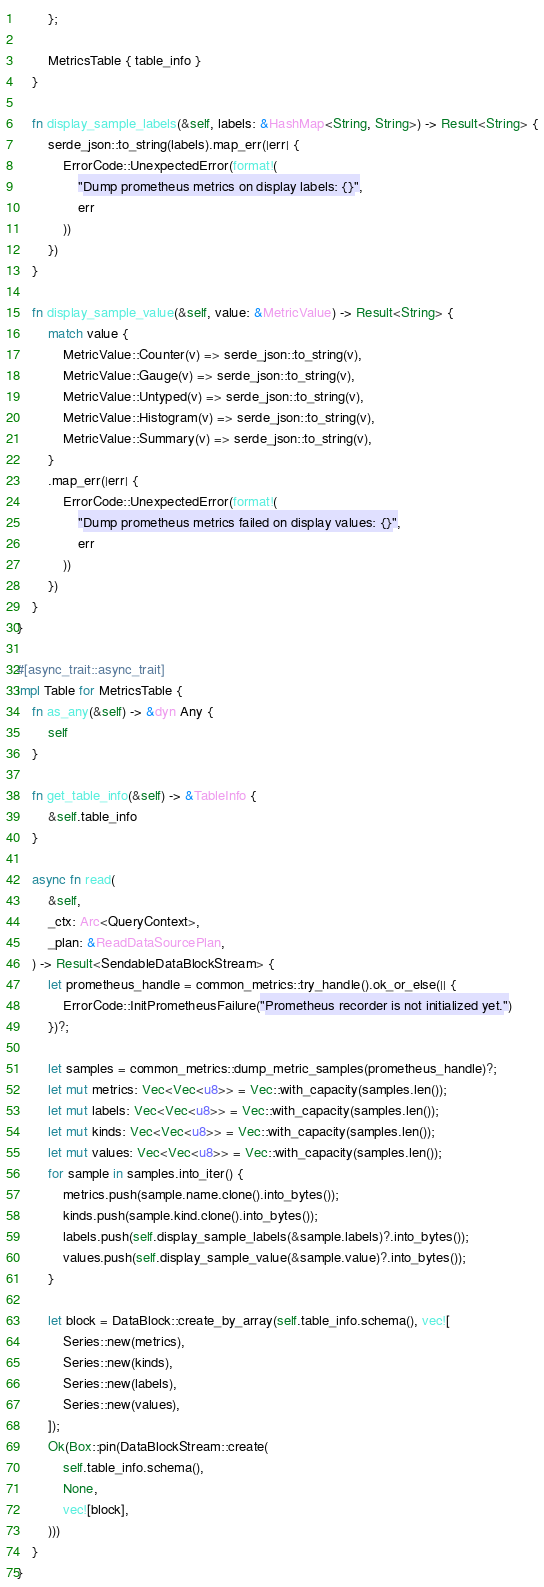Convert code to text. <code><loc_0><loc_0><loc_500><loc_500><_Rust_>        };

        MetricsTable { table_info }
    }

    fn display_sample_labels(&self, labels: &HashMap<String, String>) -> Result<String> {
        serde_json::to_string(labels).map_err(|err| {
            ErrorCode::UnexpectedError(format!(
                "Dump prometheus metrics on display labels: {}",
                err
            ))
        })
    }

    fn display_sample_value(&self, value: &MetricValue) -> Result<String> {
        match value {
            MetricValue::Counter(v) => serde_json::to_string(v),
            MetricValue::Gauge(v) => serde_json::to_string(v),
            MetricValue::Untyped(v) => serde_json::to_string(v),
            MetricValue::Histogram(v) => serde_json::to_string(v),
            MetricValue::Summary(v) => serde_json::to_string(v),
        }
        .map_err(|err| {
            ErrorCode::UnexpectedError(format!(
                "Dump prometheus metrics failed on display values: {}",
                err
            ))
        })
    }
}

#[async_trait::async_trait]
impl Table for MetricsTable {
    fn as_any(&self) -> &dyn Any {
        self
    }

    fn get_table_info(&self) -> &TableInfo {
        &self.table_info
    }

    async fn read(
        &self,
        _ctx: Arc<QueryContext>,
        _plan: &ReadDataSourcePlan,
    ) -> Result<SendableDataBlockStream> {
        let prometheus_handle = common_metrics::try_handle().ok_or_else(|| {
            ErrorCode::InitPrometheusFailure("Prometheus recorder is not initialized yet.")
        })?;

        let samples = common_metrics::dump_metric_samples(prometheus_handle)?;
        let mut metrics: Vec<Vec<u8>> = Vec::with_capacity(samples.len());
        let mut labels: Vec<Vec<u8>> = Vec::with_capacity(samples.len());
        let mut kinds: Vec<Vec<u8>> = Vec::with_capacity(samples.len());
        let mut values: Vec<Vec<u8>> = Vec::with_capacity(samples.len());
        for sample in samples.into_iter() {
            metrics.push(sample.name.clone().into_bytes());
            kinds.push(sample.kind.clone().into_bytes());
            labels.push(self.display_sample_labels(&sample.labels)?.into_bytes());
            values.push(self.display_sample_value(&sample.value)?.into_bytes());
        }

        let block = DataBlock::create_by_array(self.table_info.schema(), vec![
            Series::new(metrics),
            Series::new(kinds),
            Series::new(labels),
            Series::new(values),
        ]);
        Ok(Box::pin(DataBlockStream::create(
            self.table_info.schema(),
            None,
            vec![block],
        )))
    }
}
</code> 